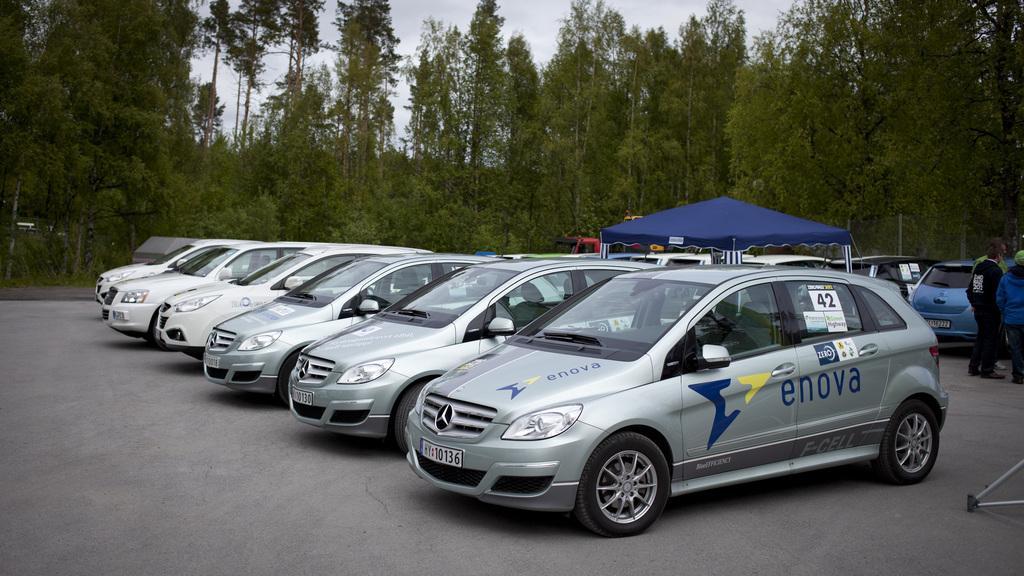Can you describe this image briefly? In this picture we can see some cars, there is a tent in the middle, we can see some trees in the background, there is the sky at the top of the picture, on the right side we can see three persons standing. 